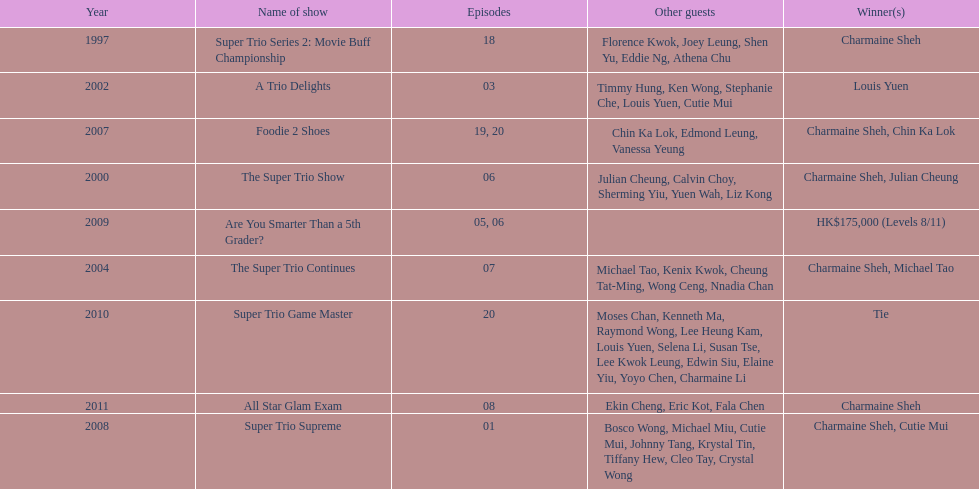What is the number of tv shows that charmaine sheh has appeared on? 9. 